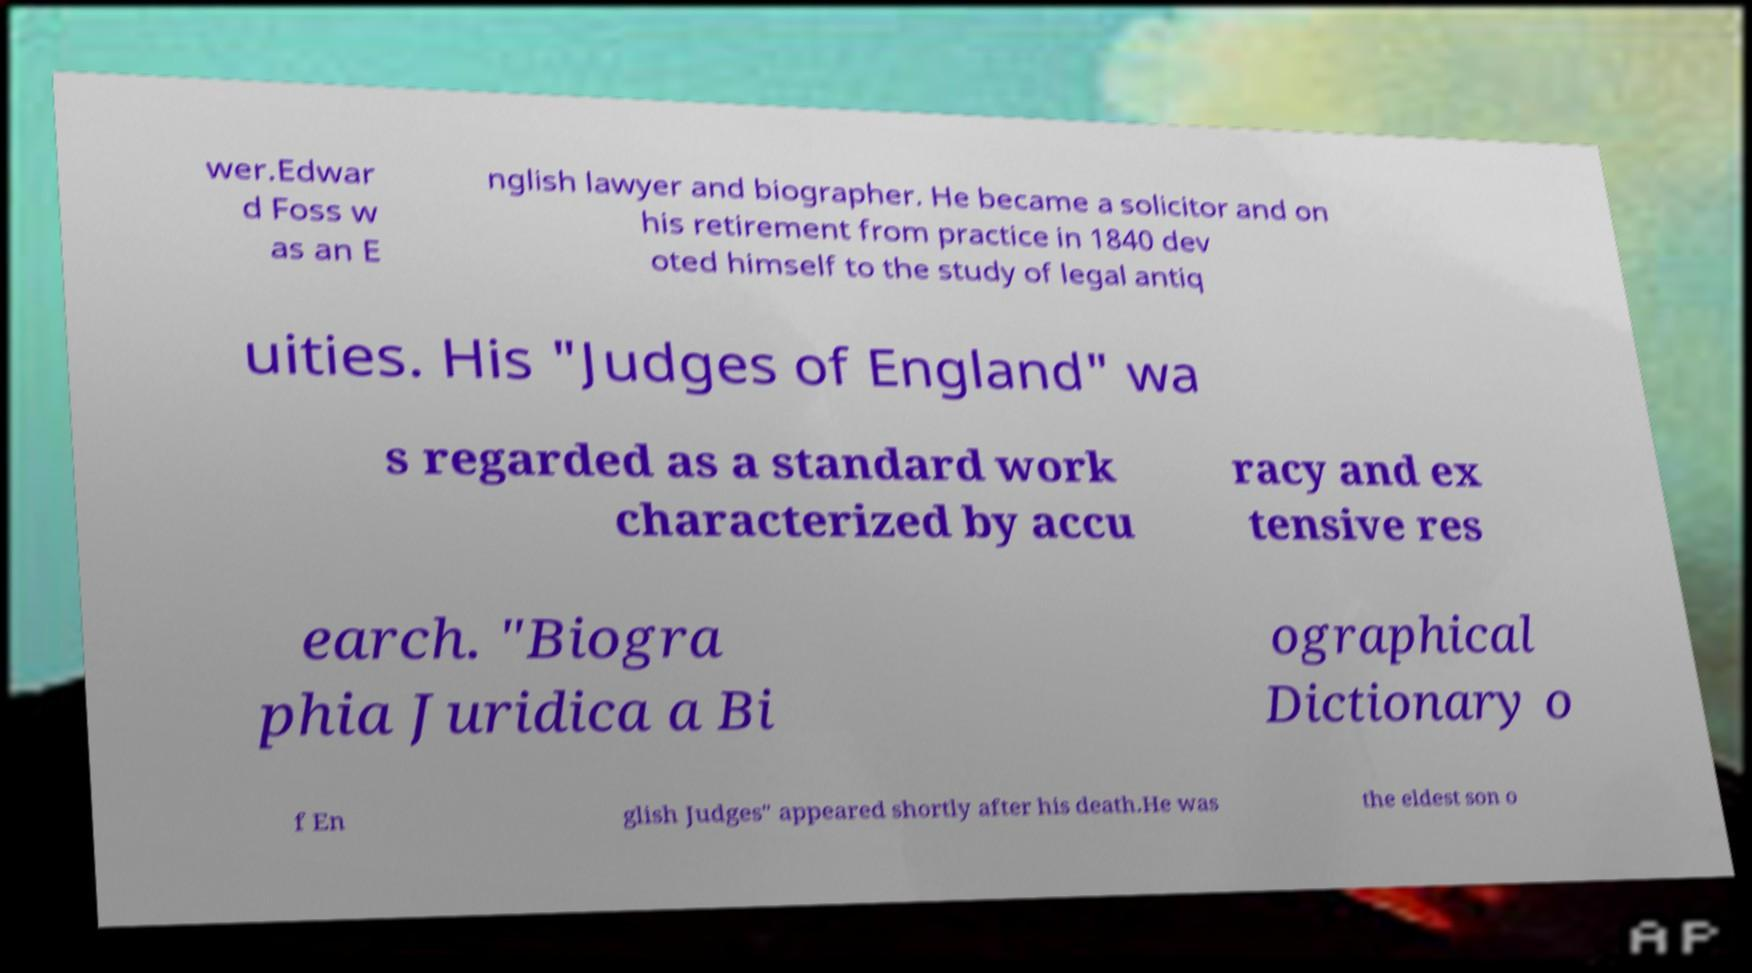There's text embedded in this image that I need extracted. Can you transcribe it verbatim? wer.Edwar d Foss w as an E nglish lawyer and biographer. He became a solicitor and on his retirement from practice in 1840 dev oted himself to the study of legal antiq uities. His "Judges of England" wa s regarded as a standard work characterized by accu racy and ex tensive res earch. "Biogra phia Juridica a Bi ographical Dictionary o f En glish Judges" appeared shortly after his death.He was the eldest son o 